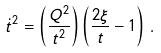<formula> <loc_0><loc_0><loc_500><loc_500>\dot { t } ^ { 2 } = \left ( \frac { Q ^ { 2 } } { t ^ { 2 } } \right ) \left ( \frac { 2 \xi } { t } - 1 \right ) \, .</formula> 